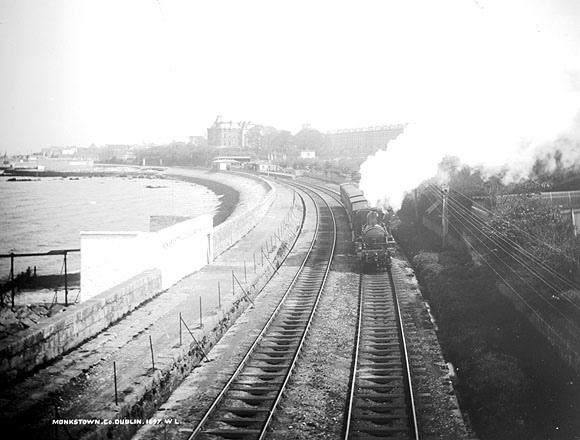Is it a clear day?
Short answer required. No. What is the train coming over?
Answer briefly. Tracks. Is the photo old?
Keep it brief. Yes. What form of transportation is that?
Write a very short answer. Train. What is coming out of the train?
Short answer required. Smoke. Is there a bridge?
Be succinct. No. How many train tracks are there?
Concise answer only. 2. 